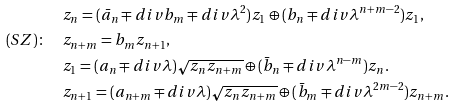Convert formula to latex. <formula><loc_0><loc_0><loc_500><loc_500>& z _ { n } = ( \bar { a } _ { n } \mp d i v b _ { m } \mp d i v \lambda ^ { 2 } ) z _ { 1 } \oplus ( b _ { n } \mp d i v \lambda ^ { n + m - 2 } ) z _ { 1 } , \\ ( S Z ) \colon \quad & z _ { n + m } = b _ { m } z _ { n + 1 } , \\ & z _ { 1 } = ( a _ { n } \mp d i v \lambda ) \sqrt { z _ { n } z _ { n + m } } \oplus ( \bar { b } _ { n } \mp d i v \lambda ^ { n - m } ) z _ { n } . \\ & z _ { n + 1 } = ( a _ { n + m } \mp d i v \lambda ) \sqrt { z _ { n } z _ { n + m } } \oplus ( \bar { b } _ { m } \mp d i v \lambda ^ { 2 m - 2 } ) z _ { n + m } .</formula> 